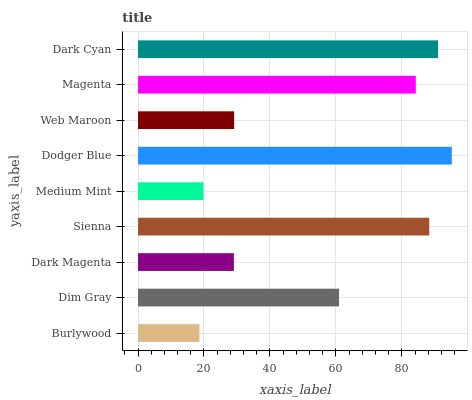Is Burlywood the minimum?
Answer yes or no. Yes. Is Dodger Blue the maximum?
Answer yes or no. Yes. Is Dim Gray the minimum?
Answer yes or no. No. Is Dim Gray the maximum?
Answer yes or no. No. Is Dim Gray greater than Burlywood?
Answer yes or no. Yes. Is Burlywood less than Dim Gray?
Answer yes or no. Yes. Is Burlywood greater than Dim Gray?
Answer yes or no. No. Is Dim Gray less than Burlywood?
Answer yes or no. No. Is Dim Gray the high median?
Answer yes or no. Yes. Is Dim Gray the low median?
Answer yes or no. Yes. Is Dark Magenta the high median?
Answer yes or no. No. Is Web Maroon the low median?
Answer yes or no. No. 